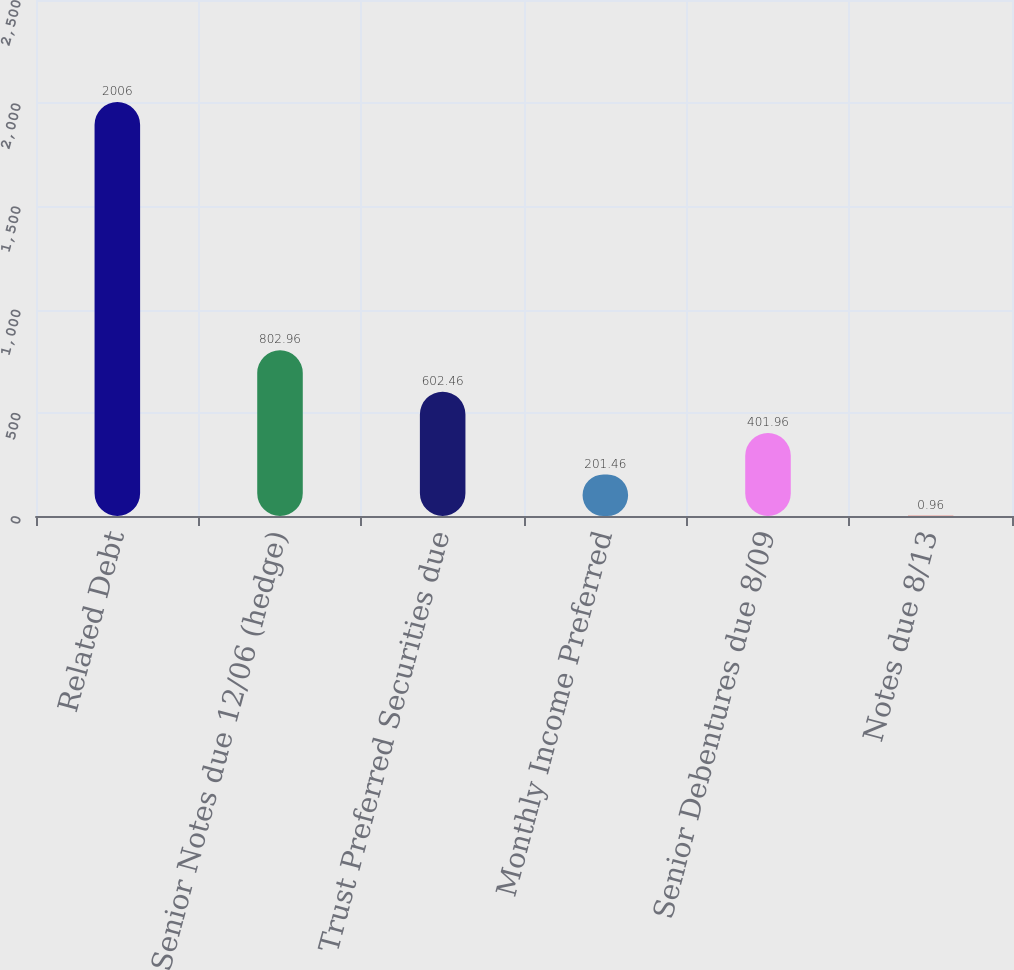Convert chart to OTSL. <chart><loc_0><loc_0><loc_500><loc_500><bar_chart><fcel>Related Debt<fcel>Senior Notes due 12/06 (hedge)<fcel>Trust Preferred Securities due<fcel>Monthly Income Preferred<fcel>Senior Debentures due 8/09<fcel>Notes due 8/13<nl><fcel>2006<fcel>802.96<fcel>602.46<fcel>201.46<fcel>401.96<fcel>0.96<nl></chart> 